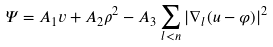<formula> <loc_0><loc_0><loc_500><loc_500>\varPsi = A _ { 1 } v + A _ { 2 } \rho ^ { 2 } - A _ { 3 } \sum _ { l < n } | \nabla _ { l } ( u - \varphi ) | ^ { 2 }</formula> 